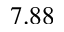Convert formula to latex. <formula><loc_0><loc_0><loc_500><loc_500>7 . 8 8</formula> 